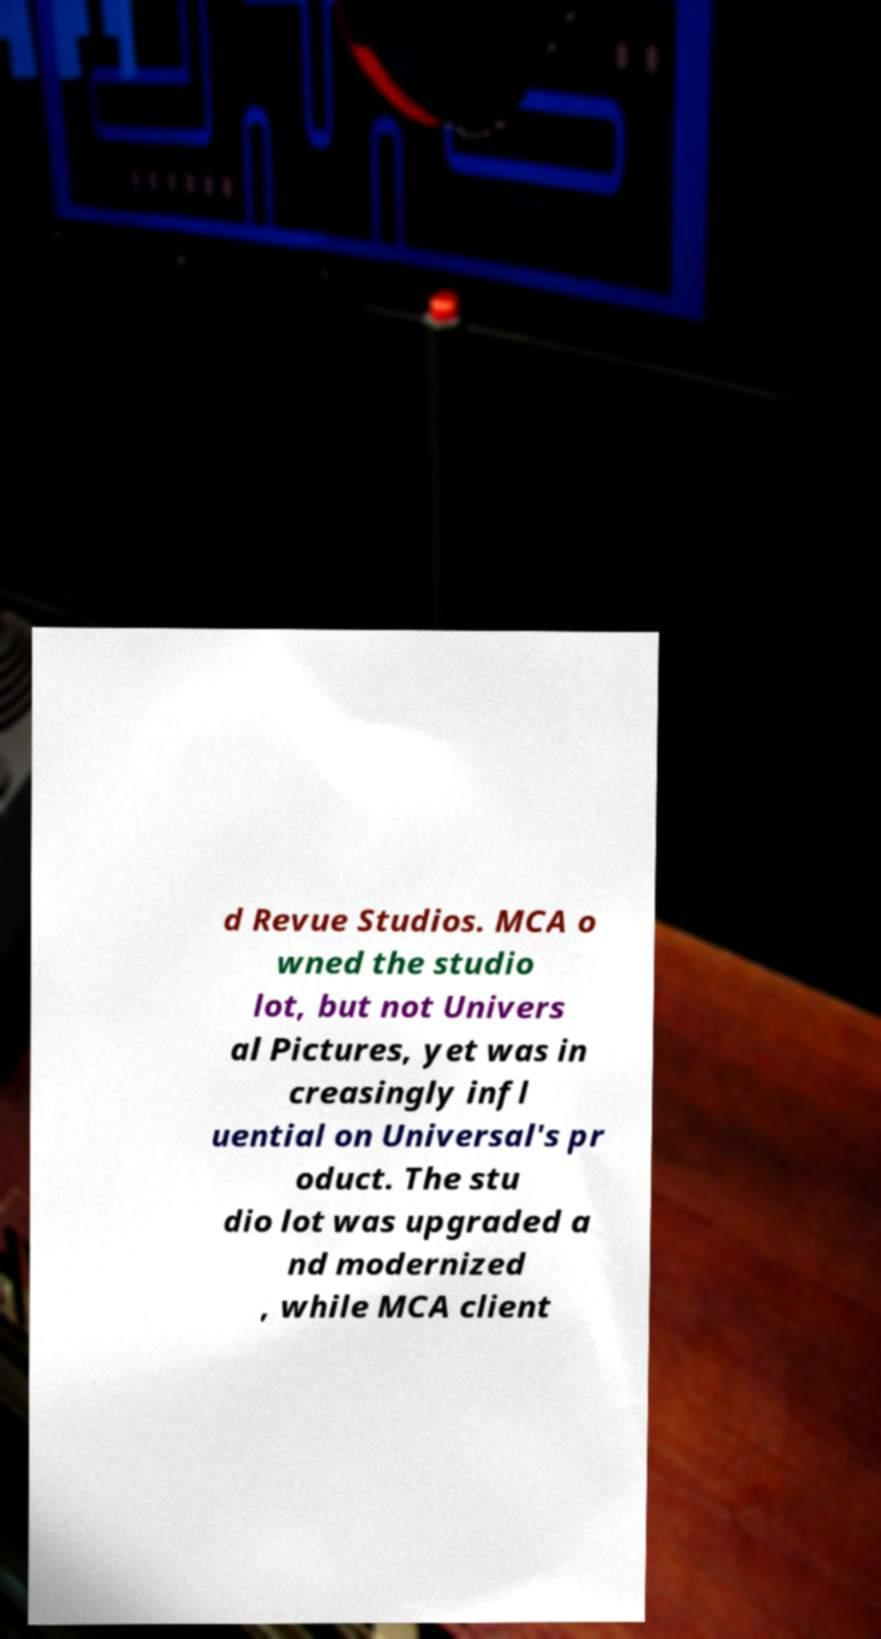Could you assist in decoding the text presented in this image and type it out clearly? d Revue Studios. MCA o wned the studio lot, but not Univers al Pictures, yet was in creasingly infl uential on Universal's pr oduct. The stu dio lot was upgraded a nd modernized , while MCA client 